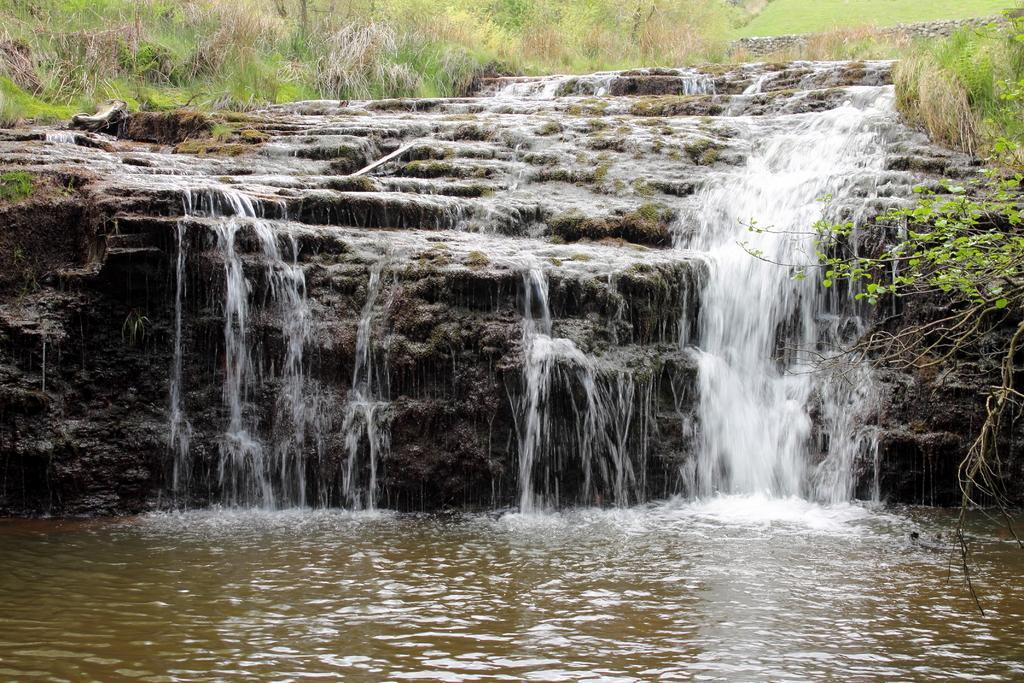How would you summarize this image in a sentence or two? In this image there is a waterfall, behind the waterfall there is grass. 